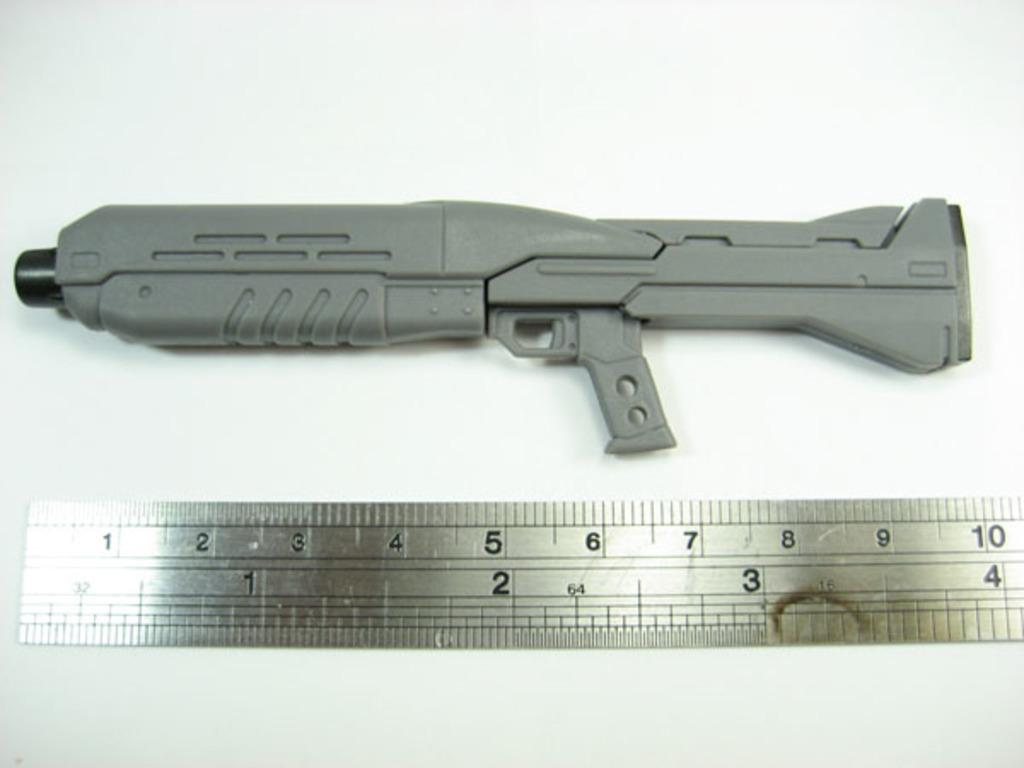Provide a one-sentence caption for the provided image. A weapon and a ruler underneath showing that it is 10 inches. 